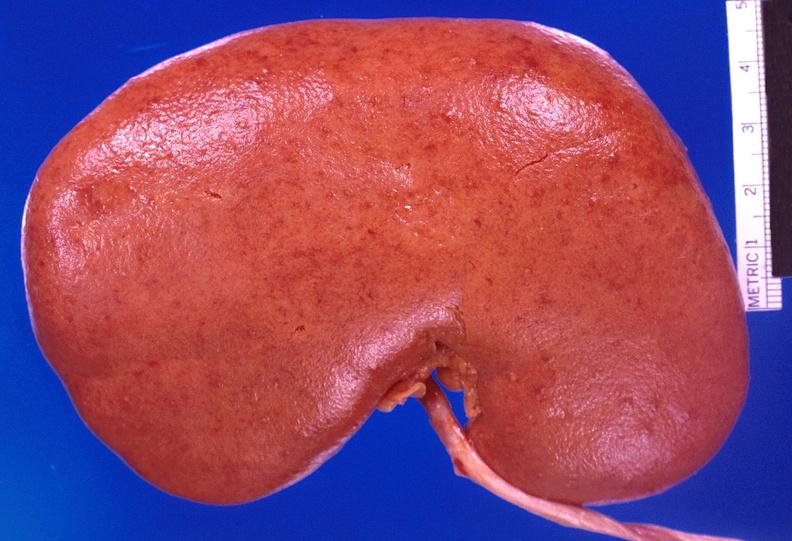does this image show kidney, candida abscesses?
Answer the question using a single word or phrase. Yes 